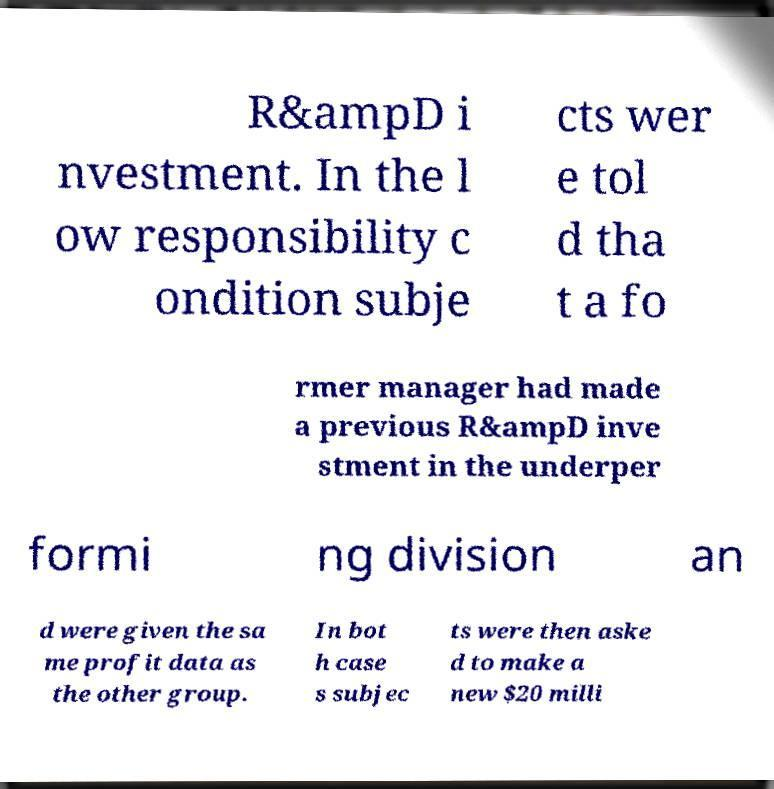Could you assist in decoding the text presented in this image and type it out clearly? R&ampD i nvestment. In the l ow responsibility c ondition subje cts wer e tol d tha t a fo rmer manager had made a previous R&ampD inve stment in the underper formi ng division an d were given the sa me profit data as the other group. In bot h case s subjec ts were then aske d to make a new $20 milli 